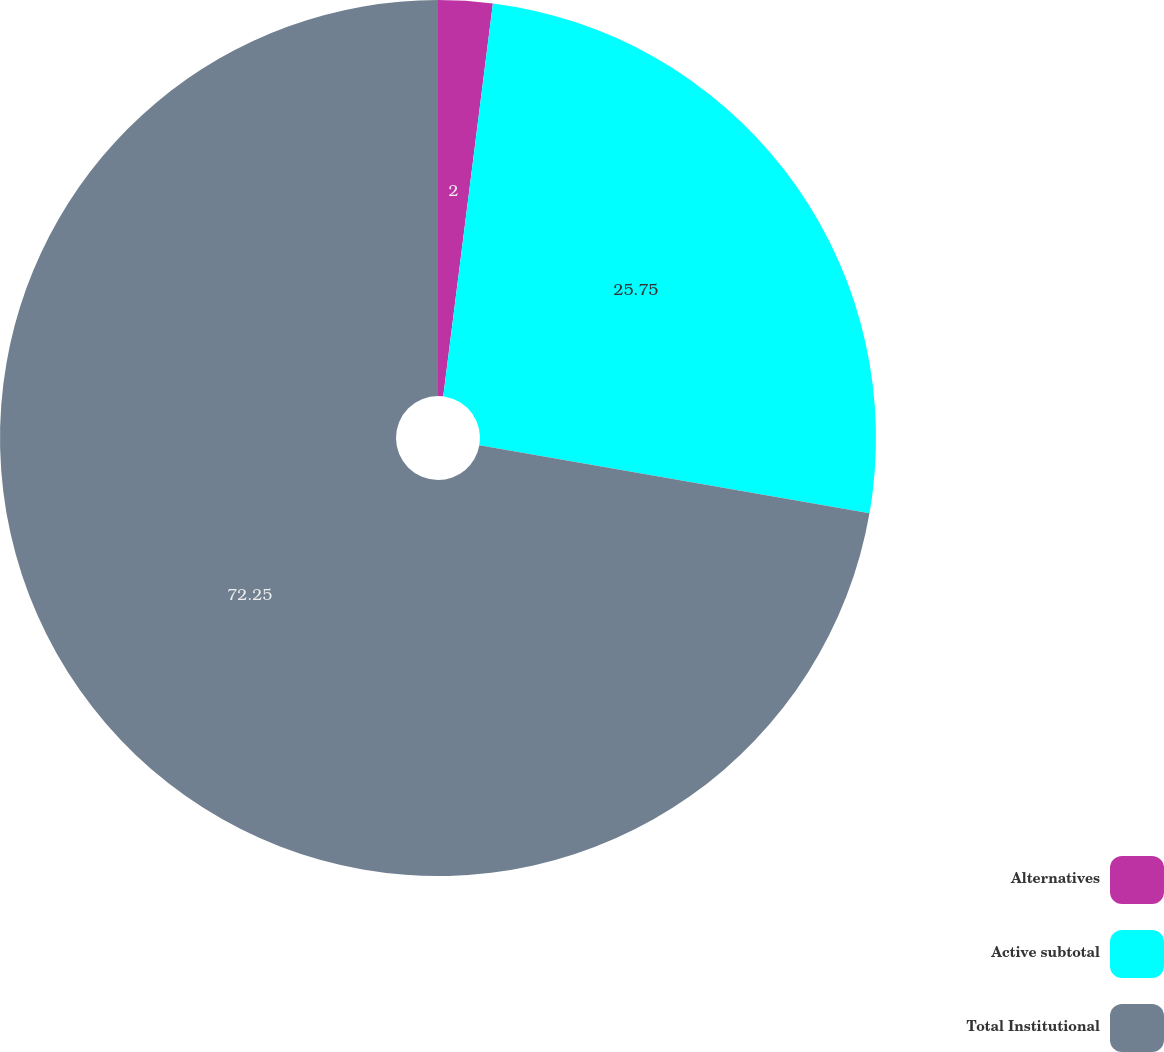<chart> <loc_0><loc_0><loc_500><loc_500><pie_chart><fcel>Alternatives<fcel>Active subtotal<fcel>Total Institutional<nl><fcel>2.0%<fcel>25.75%<fcel>72.25%<nl></chart> 